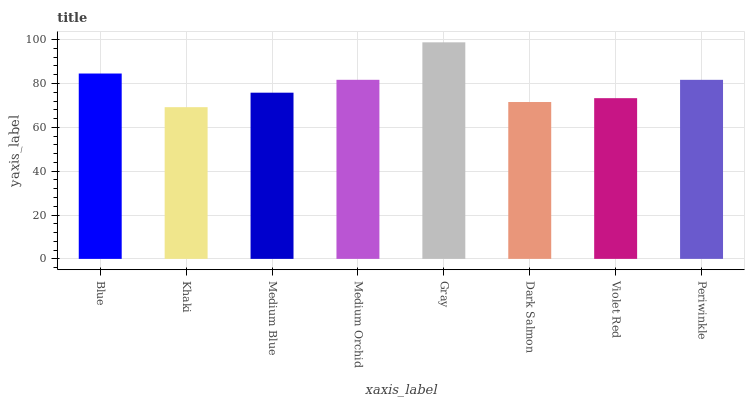Is Khaki the minimum?
Answer yes or no. Yes. Is Gray the maximum?
Answer yes or no. Yes. Is Medium Blue the minimum?
Answer yes or no. No. Is Medium Blue the maximum?
Answer yes or no. No. Is Medium Blue greater than Khaki?
Answer yes or no. Yes. Is Khaki less than Medium Blue?
Answer yes or no. Yes. Is Khaki greater than Medium Blue?
Answer yes or no. No. Is Medium Blue less than Khaki?
Answer yes or no. No. Is Periwinkle the high median?
Answer yes or no. Yes. Is Medium Blue the low median?
Answer yes or no. Yes. Is Gray the high median?
Answer yes or no. No. Is Periwinkle the low median?
Answer yes or no. No. 